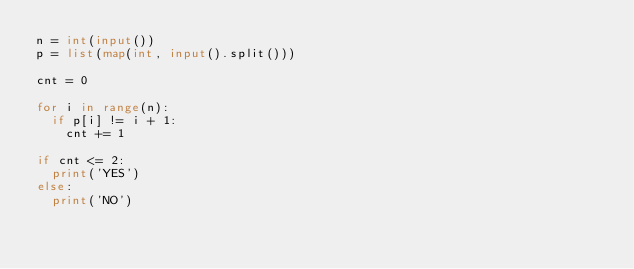Convert code to text. <code><loc_0><loc_0><loc_500><loc_500><_Python_>n = int(input())
p = list(map(int, input().split()))

cnt = 0

for i in range(n):
  if p[i] != i + 1:
    cnt += 1
    
if cnt <= 2:
  print('YES')
else:
  print('NO')</code> 